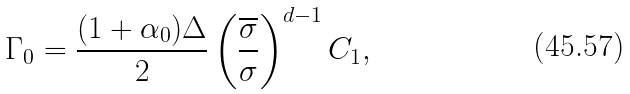<formula> <loc_0><loc_0><loc_500><loc_500>\Gamma _ { 0 } = \frac { ( 1 + \alpha _ { 0 } ) \Delta } { 2 } \left ( \frac { \overline { \sigma } } { \sigma } \right ) ^ { d - 1 } C _ { 1 } ,</formula> 